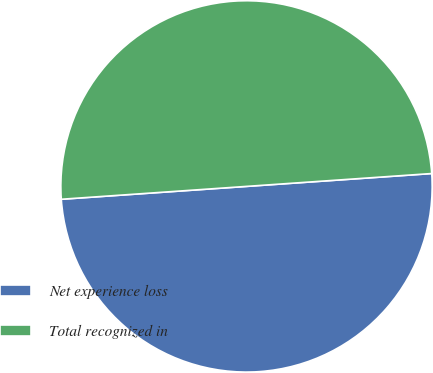Convert chart to OTSL. <chart><loc_0><loc_0><loc_500><loc_500><pie_chart><fcel>Net experience loss<fcel>Total recognized in<nl><fcel>50.0%<fcel>50.0%<nl></chart> 